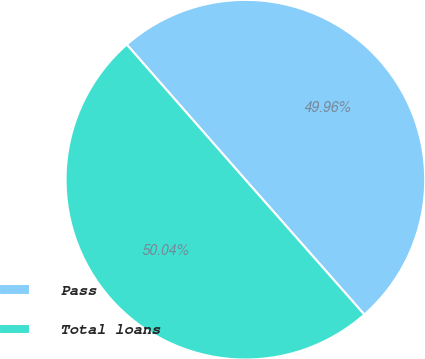Convert chart to OTSL. <chart><loc_0><loc_0><loc_500><loc_500><pie_chart><fcel>Pass<fcel>Total loans<nl><fcel>49.96%<fcel>50.04%<nl></chart> 